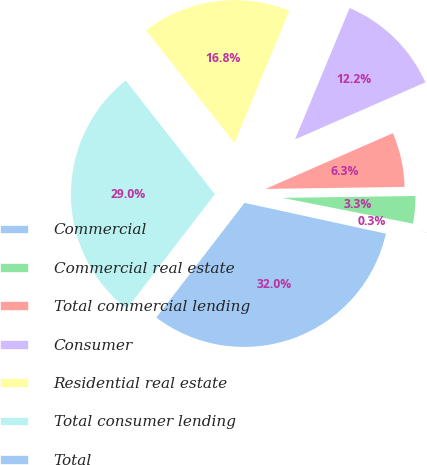<chart> <loc_0><loc_0><loc_500><loc_500><pie_chart><fcel>Commercial<fcel>Commercial real estate<fcel>Total commercial lending<fcel>Consumer<fcel>Residential real estate<fcel>Total consumer lending<fcel>Total<nl><fcel>0.31%<fcel>3.33%<fcel>6.34%<fcel>12.17%<fcel>16.83%<fcel>29.0%<fcel>32.02%<nl></chart> 